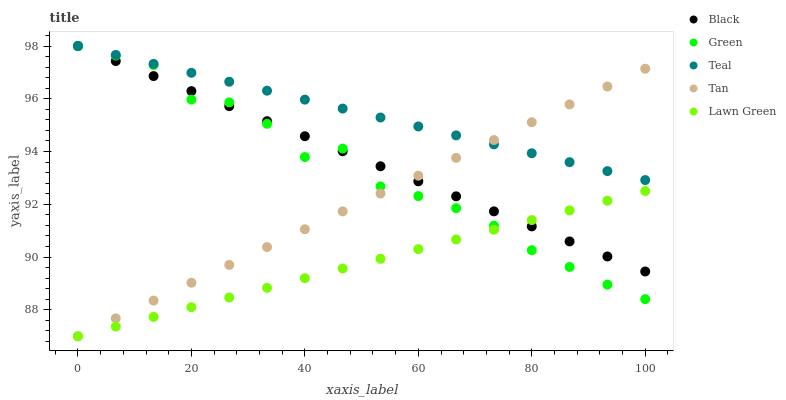Does Lawn Green have the minimum area under the curve?
Answer yes or no. Yes. Does Teal have the maximum area under the curve?
Answer yes or no. Yes. Does Tan have the minimum area under the curve?
Answer yes or no. No. Does Tan have the maximum area under the curve?
Answer yes or no. No. Is Black the smoothest?
Answer yes or no. Yes. Is Green the roughest?
Answer yes or no. Yes. Is Tan the smoothest?
Answer yes or no. No. Is Tan the roughest?
Answer yes or no. No. Does Tan have the lowest value?
Answer yes or no. Yes. Does Black have the lowest value?
Answer yes or no. No. Does Teal have the highest value?
Answer yes or no. Yes. Does Tan have the highest value?
Answer yes or no. No. Is Lawn Green less than Teal?
Answer yes or no. Yes. Is Teal greater than Lawn Green?
Answer yes or no. Yes. Does Black intersect Tan?
Answer yes or no. Yes. Is Black less than Tan?
Answer yes or no. No. Is Black greater than Tan?
Answer yes or no. No. Does Lawn Green intersect Teal?
Answer yes or no. No. 